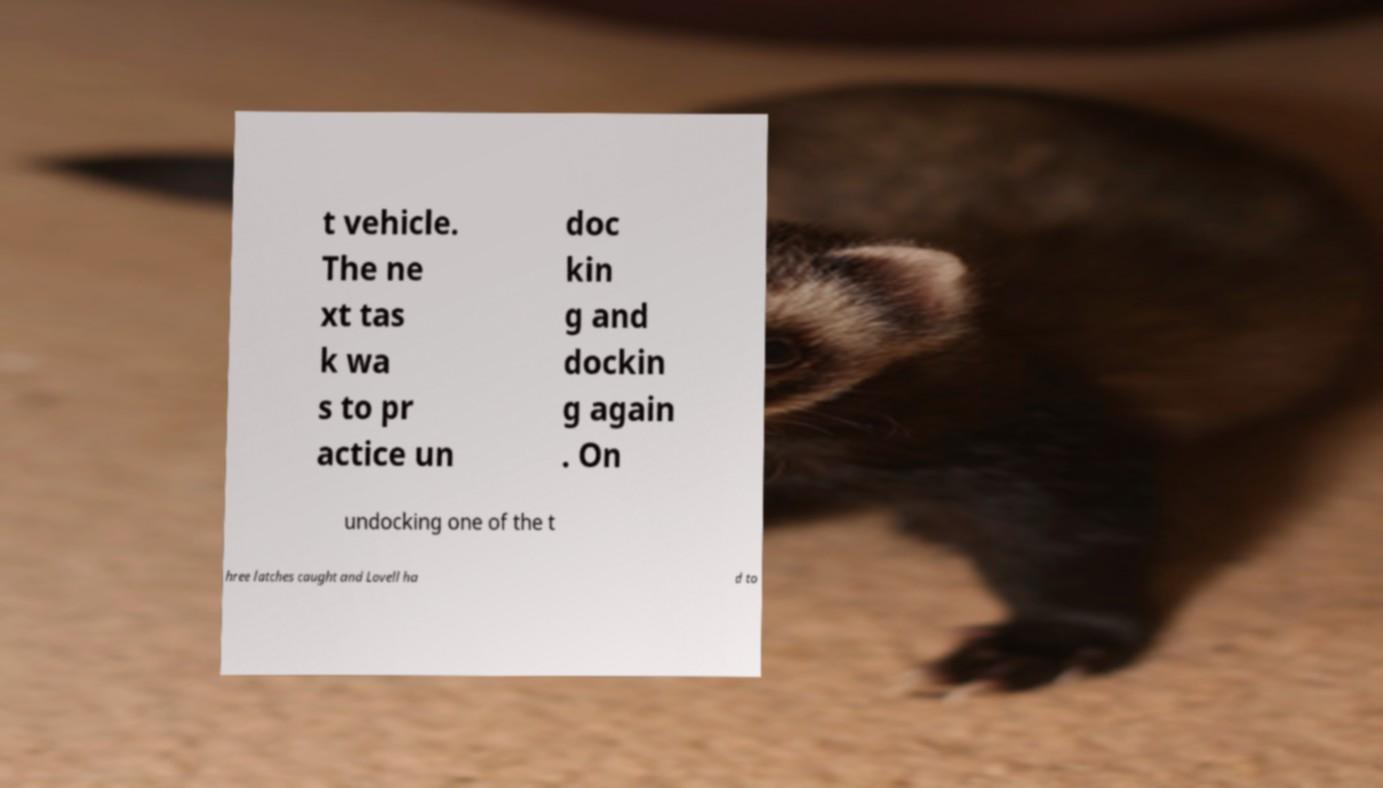There's text embedded in this image that I need extracted. Can you transcribe it verbatim? t vehicle. The ne xt tas k wa s to pr actice un doc kin g and dockin g again . On undocking one of the t hree latches caught and Lovell ha d to 